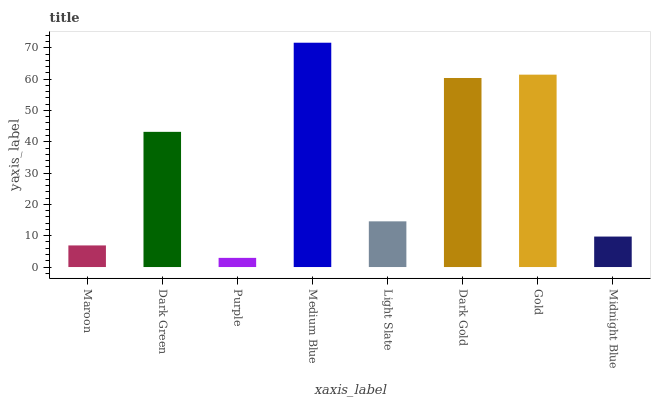Is Purple the minimum?
Answer yes or no. Yes. Is Medium Blue the maximum?
Answer yes or no. Yes. Is Dark Green the minimum?
Answer yes or no. No. Is Dark Green the maximum?
Answer yes or no. No. Is Dark Green greater than Maroon?
Answer yes or no. Yes. Is Maroon less than Dark Green?
Answer yes or no. Yes. Is Maroon greater than Dark Green?
Answer yes or no. No. Is Dark Green less than Maroon?
Answer yes or no. No. Is Dark Green the high median?
Answer yes or no. Yes. Is Light Slate the low median?
Answer yes or no. Yes. Is Medium Blue the high median?
Answer yes or no. No. Is Midnight Blue the low median?
Answer yes or no. No. 